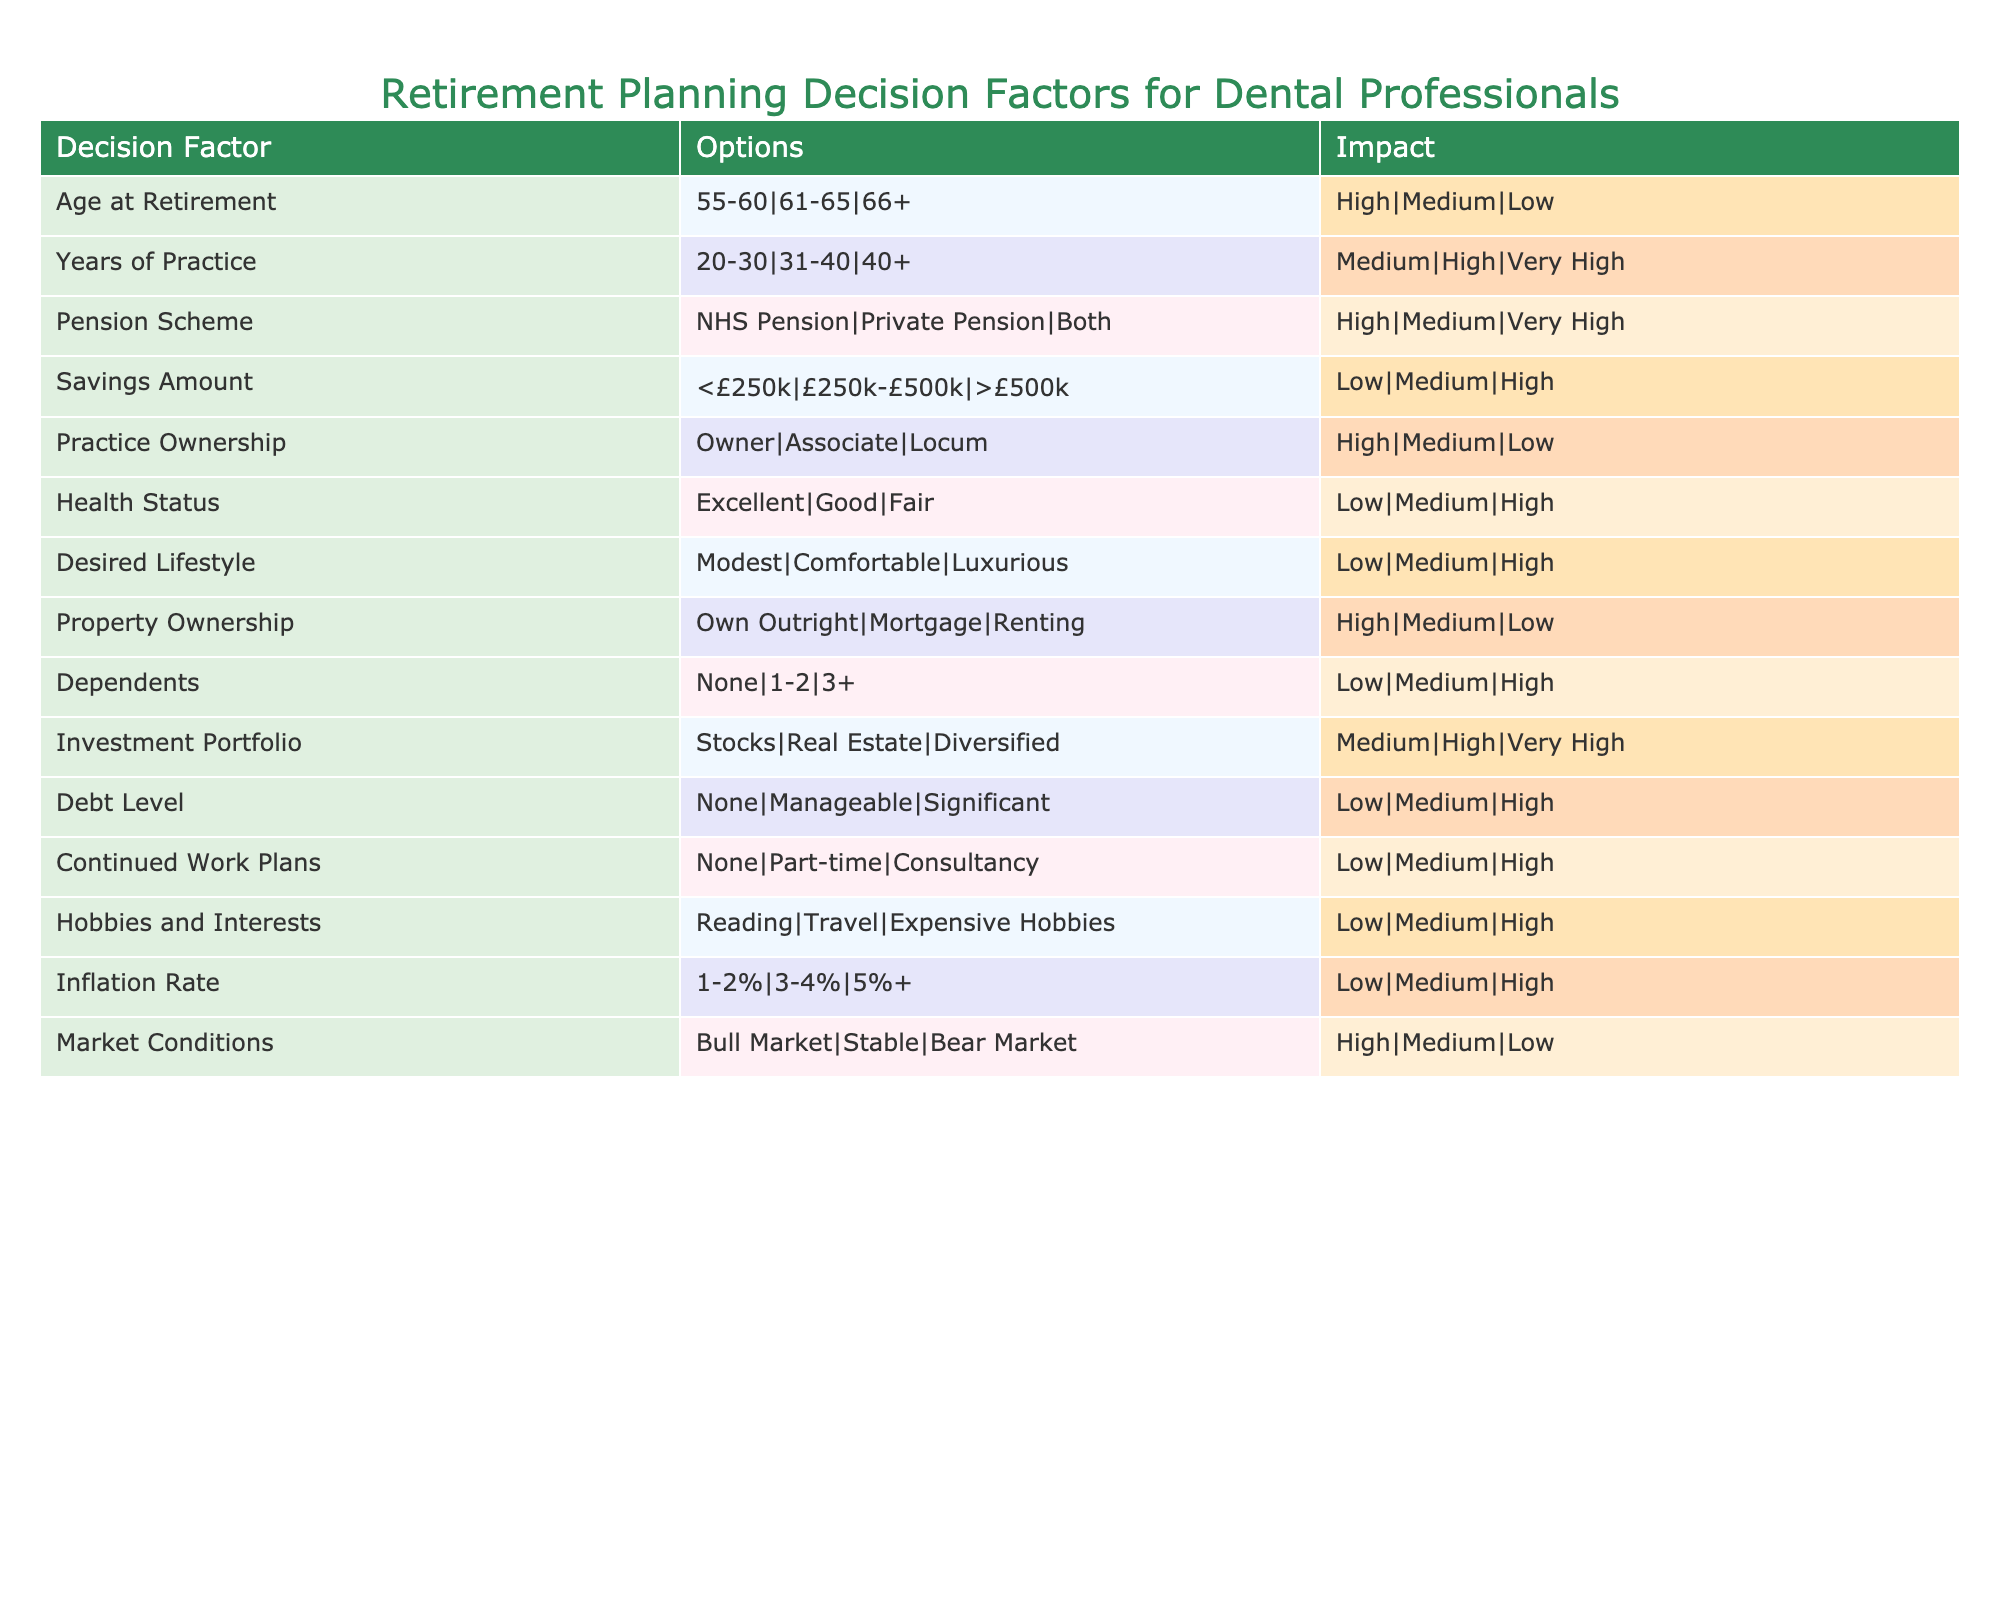What is the impact of retiring at age 66 or older? The table indicates that retiring at age 66+ is associated with a low impact. This is derived from the "Age at Retirement" row where the impact for this age group is labeled as "Low."
Answer: Low How does having dependents impact retirement planning? According to the table, having 3 or more dependents leads to a high impact on retirement planning, as shown in the "Dependents" row where this option is noted as "High."
Answer: High What is the combined impact of having a private pension and low savings (£250k) for a dental professional? The impact of a Private Pension is medium and the impact of savings below £250k is low. The overall combined impact will depend on further contextual factors; however, the maximum score from these two would be medium when both are considered.
Answer: Medium Is it better to have an investment portfolio that is diversified rather than just stocks? Yes, the table indicates that a diversified investment portfolio has a very high impact, while stocks have only a medium impact. This comparison shows that diversification is more beneficial for retirement planning.
Answer: Yes If a dental professional has excellent health, what is the impact on their retirement planning? The impact of excellent health status is shown in the table as low, meaning it is less of a concern in retirement planning compared to other factors like savings and practice ownership.
Answer: Low What is the impact of practicing for 31-40 years compared to practicing for over 40 years? The table states that practicing for 31-40 years has a high impact while practicing for over 40 years has a very high impact, suggesting that longer practice years significantly enhance retirement readiness.
Answer: Very High Considering the options available for property ownership, which provides the highest impact for retirement planning? The table shows that owning property outright has a high impact, while having a mortgage is medium and renting is low. Therefore, owning property outright is the best option for higher impact in retirement planning.
Answer: High How is the impact of a bull market different from a bear market on retirement planning? A bull market has a high impact according to the table while a bear market has a low impact; this indicates that favorable market conditions significantly enhance retirement planning compared to unfavorable conditions.
Answer: High What is the average impact score for the factors associated with work plans after retirement (none, part-time, consultancy)? The impact scores for "None," "Part-time," and "Consultancy" are low, medium, and high respectively. Adding the scores (low=1, medium=2, high=3) gives 1 + 2 + 3 = 6. The average is then 6/3 = 2, which corresponds to medium impact.
Answer: Medium 